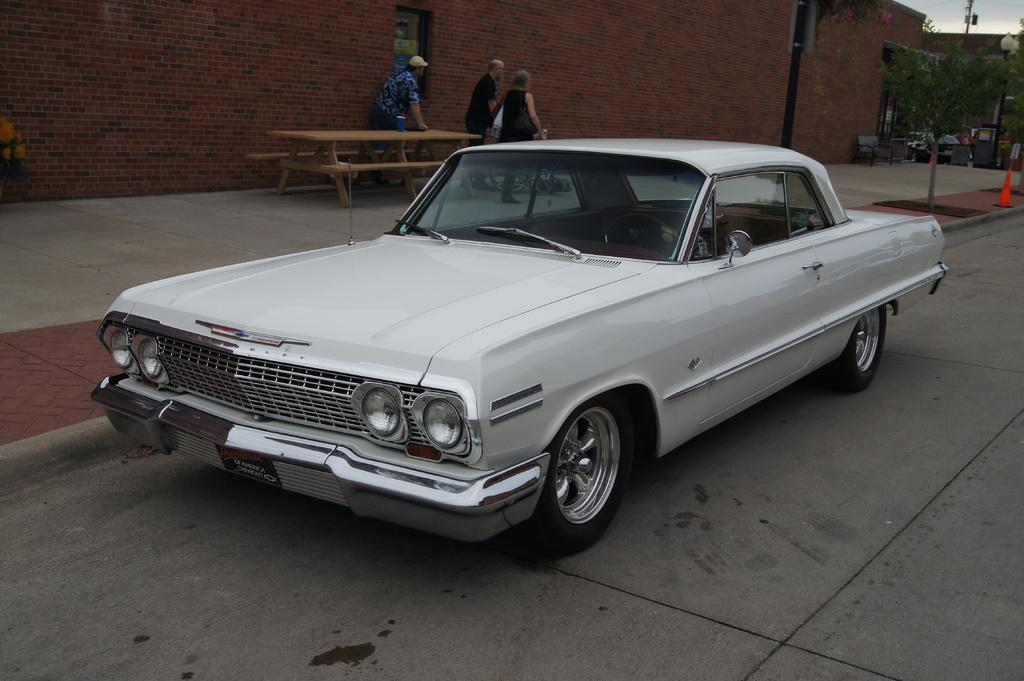What is on the ground in the image? There is a car on the ground in the image. Who or what is behind the car? There are three people behind the car. What is located behind the people? There is a bench behind the people. What can be seen in the background of the image? There is a brick wall and trees visible in the background. What type of cart is being used to act in the image? There is no cart or any act being performed in the image; it features a car, people, a bench, and a brick wall with trees in the background. 